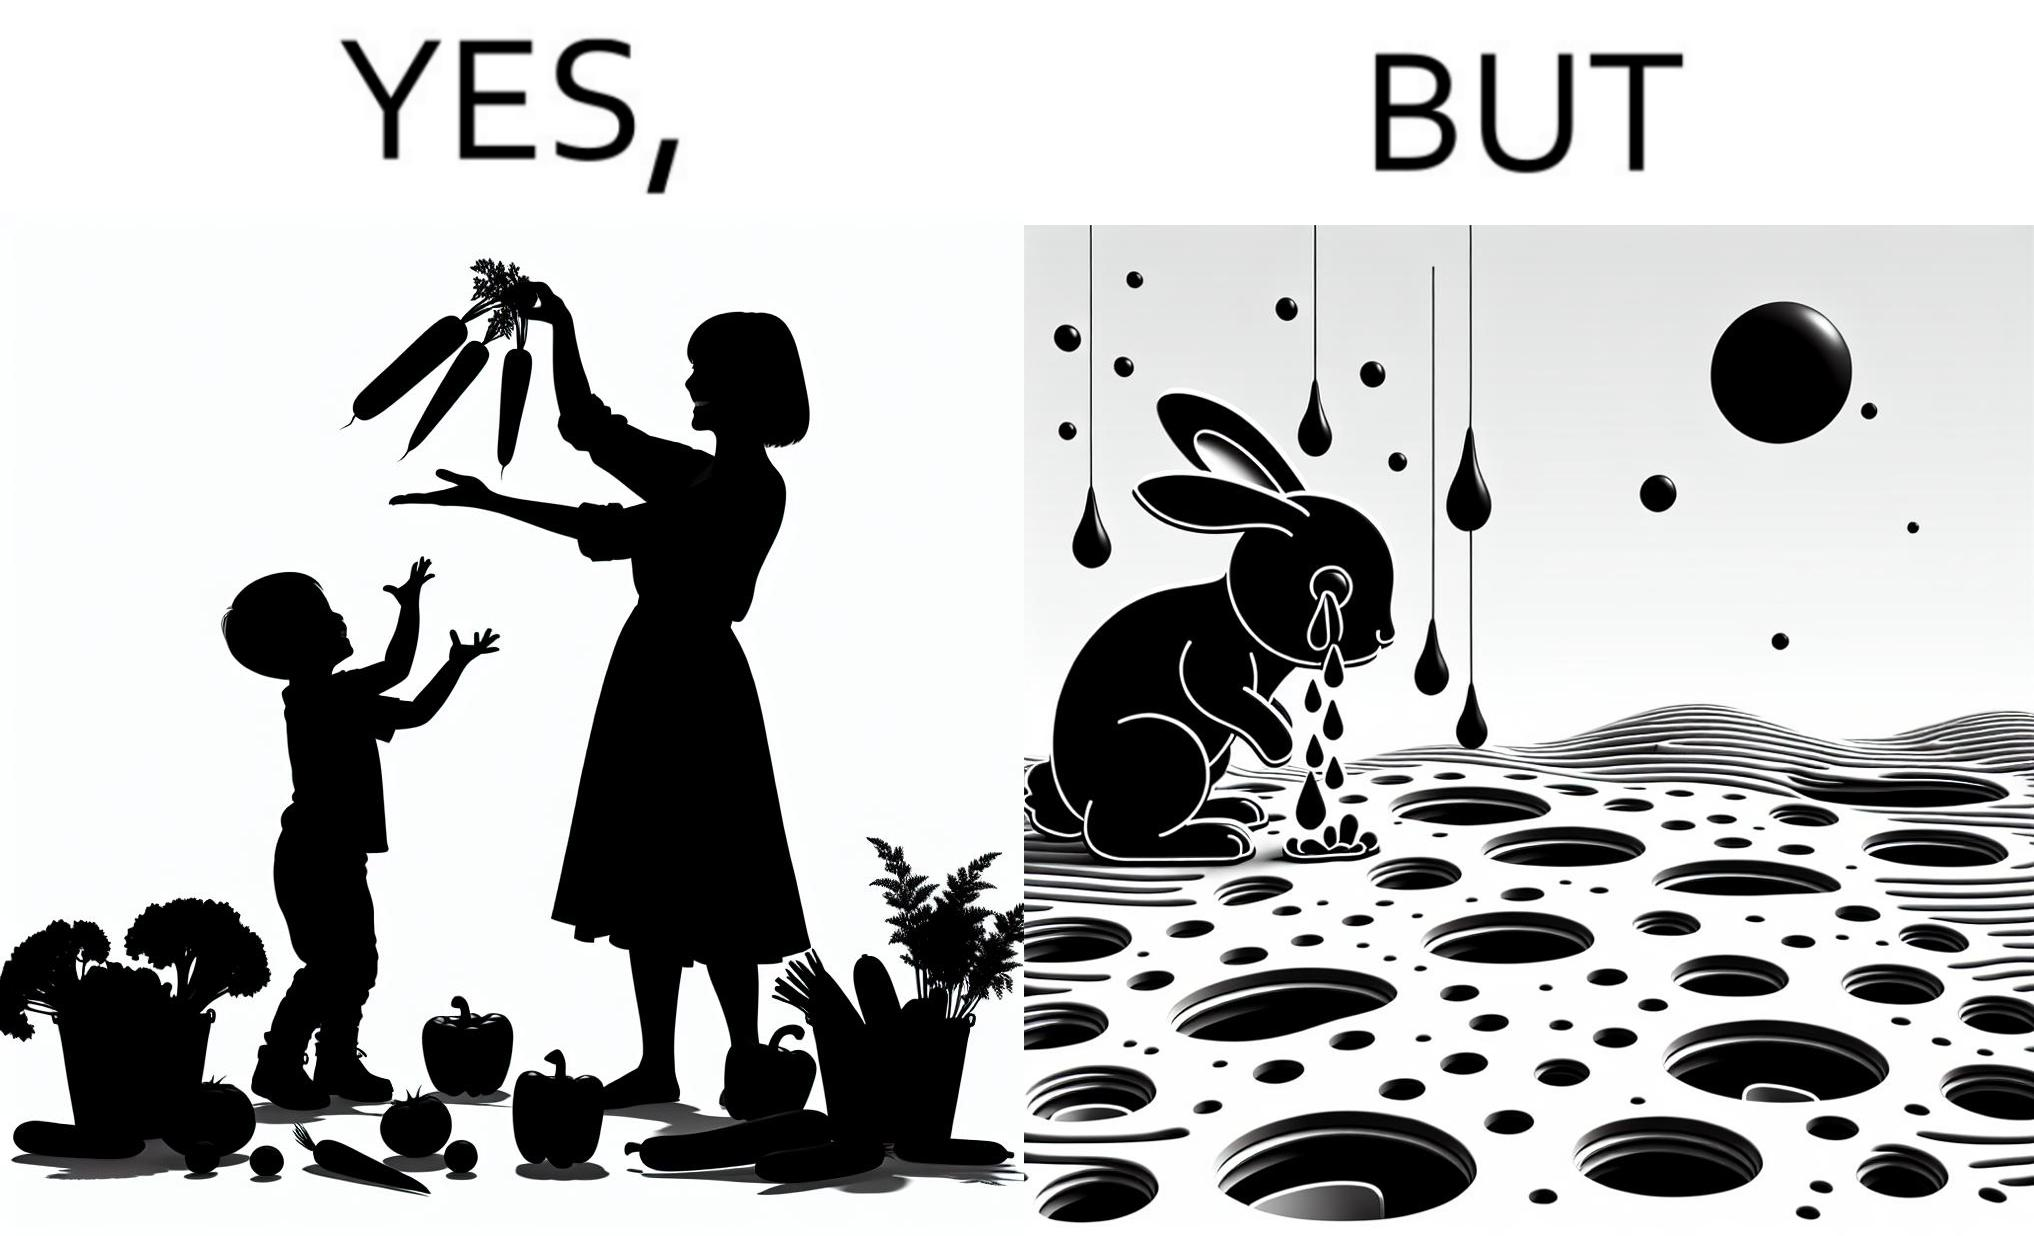Would you classify this image as satirical? Yes, this image is satirical. 